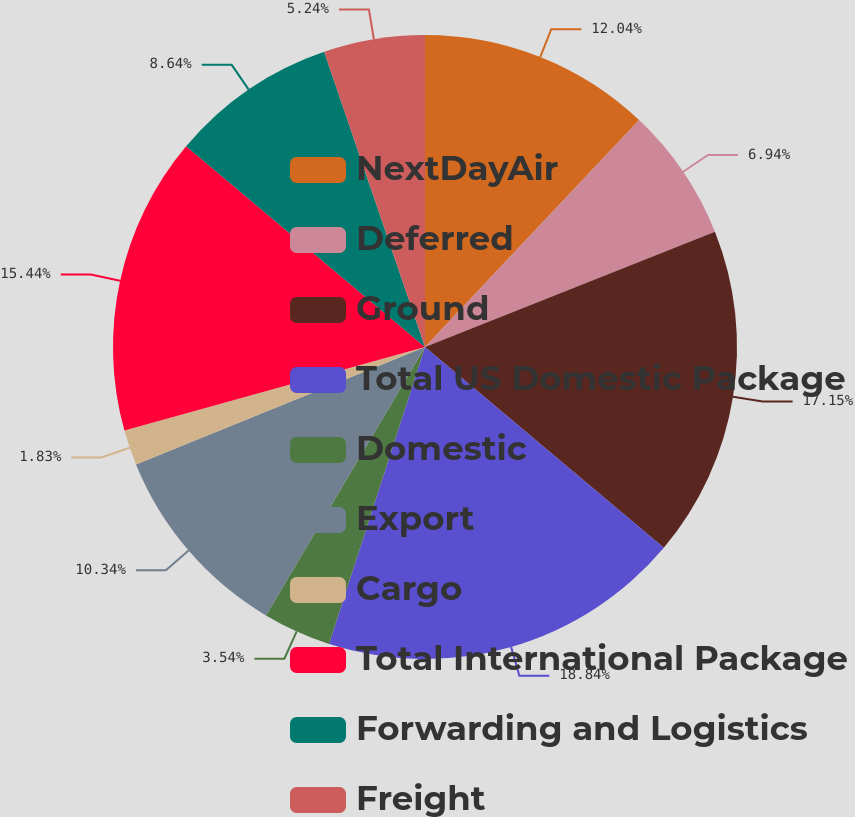Convert chart. <chart><loc_0><loc_0><loc_500><loc_500><pie_chart><fcel>NextDayAir<fcel>Deferred<fcel>Ground<fcel>Total US Domestic Package<fcel>Domestic<fcel>Export<fcel>Cargo<fcel>Total International Package<fcel>Forwarding and Logistics<fcel>Freight<nl><fcel>12.04%<fcel>6.94%<fcel>17.15%<fcel>18.85%<fcel>3.54%<fcel>10.34%<fcel>1.83%<fcel>15.44%<fcel>8.64%<fcel>5.24%<nl></chart> 